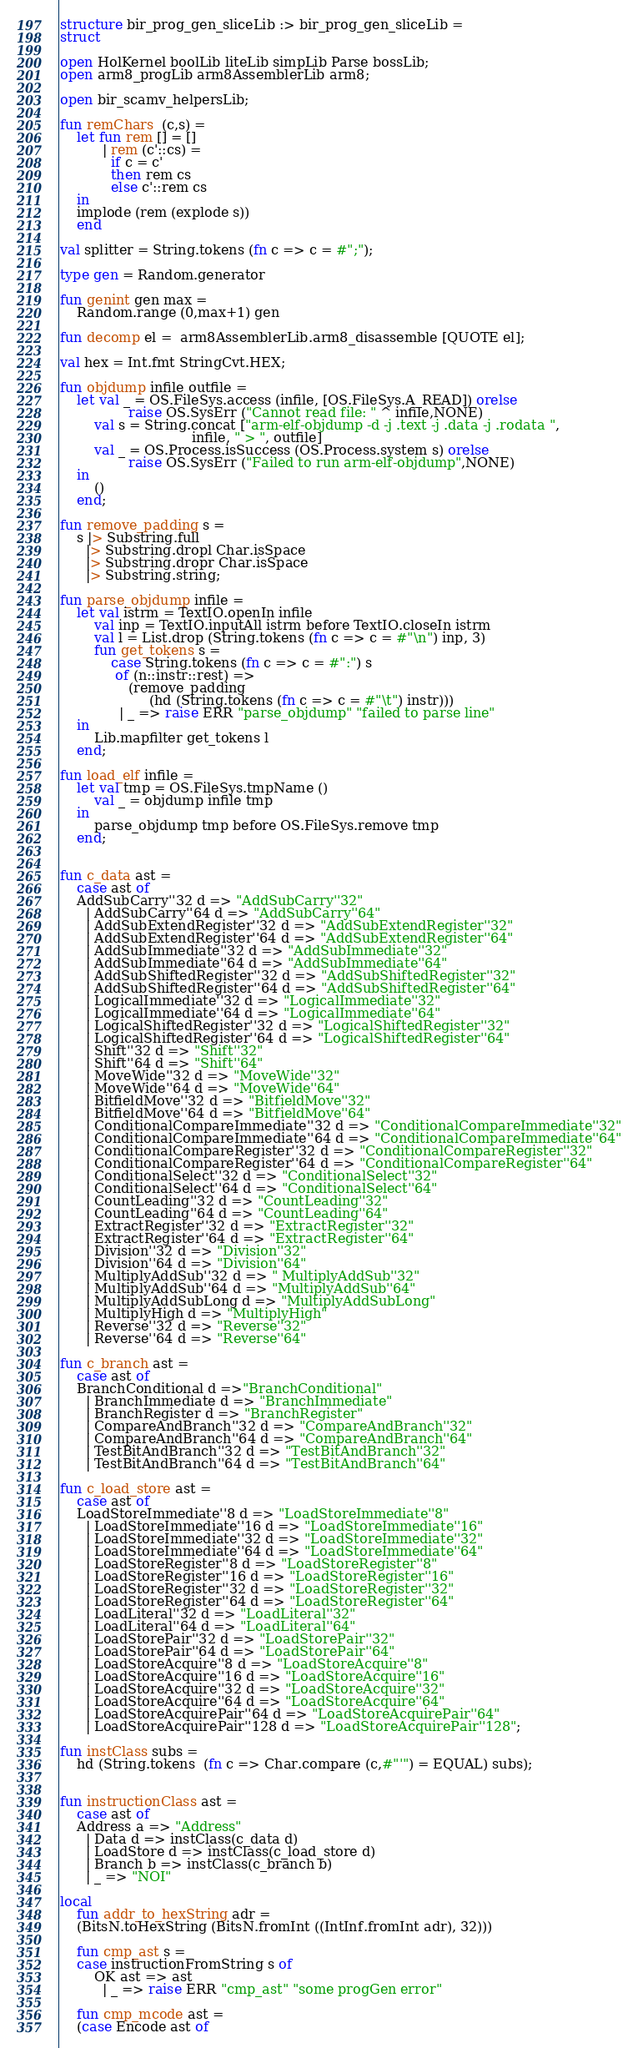<code> <loc_0><loc_0><loc_500><loc_500><_SML_>structure bir_prog_gen_sliceLib :> bir_prog_gen_sliceLib =
struct

open HolKernel boolLib liteLib simpLib Parse bossLib;
open arm8_progLib arm8AssemblerLib arm8;

open bir_scamv_helpersLib;
     
fun remChars  (c,s) =
    let fun rem [] = []
          | rem (c'::cs) =
            if c = c'
            then rem cs
            else c'::rem cs
    in
	implode (rem (explode s)) 
    end

val splitter = String.tokens (fn c => c = #";");

type gen = Random.generator

fun genint gen max =
    Random.range (0,max+1) gen     

fun decomp el =  arm8AssemblerLib.arm8_disassemble [QUOTE el];

val hex = Int.fmt StringCvt.HEX;

fun objdump infile outfile =
    let val _ = OS.FileSys.access (infile, [OS.FileSys.A_READ]) orelse
                raise OS.SysErr ("Cannot read file: " ^ infile,NONE)
        val s = String.concat ["arm-elf-objdump -d -j .text -j .data -j .rodata ",
                               infile, " > ", outfile]
        val _ = OS.Process.isSuccess (OS.Process.system s) orelse
                raise OS.SysErr ("Failed to run arm-elf-objdump",NONE)
    in
        ()
    end;

fun remove_padding s =
    s |> Substring.full
      |> Substring.dropl Char.isSpace
      |> Substring.dropr Char.isSpace
      |> Substring.string;

fun parse_objdump infile =
    let val istrm = TextIO.openIn infile
        val inp = TextIO.inputAll istrm before TextIO.closeIn istrm
        val l = List.drop (String.tokens (fn c => c = #"\n") inp, 3)
        fun get_tokens s =
            case String.tokens (fn c => c = #":") s
             of (n::instr::rest) =>
                (remove_padding
                     (hd (String.tokens (fn c => c = #"\t") instr)))
              | _ => raise ERR "parse_objdump" "failed to parse line"
    in
        Lib.mapfilter get_tokens l
    end;

fun load_elf infile =
    let val tmp = OS.FileSys.tmpName ()
        val _ = objdump infile tmp
    in
        parse_objdump tmp before OS.FileSys.remove tmp
    end;


fun c_data ast =
    case ast of
	AddSubCarry''32 d => "AddSubCarry''32"
      | AddSubCarry''64 d => "AddSubCarry''64"
      | AddSubExtendRegister''32 d => "AddSubExtendRegister''32"
      | AddSubExtendRegister''64 d => "AddSubExtendRegister''64"
      | AddSubImmediate''32 d => "AddSubImmediate''32"
      | AddSubImmediate''64 d => "AddSubImmediate''64"
      | AddSubShiftedRegister''32 d => "AddSubShiftedRegister''32"
      | AddSubShiftedRegister''64 d => "AddSubShiftedRegister''64"
      | LogicalImmediate''32 d => "LogicalImmediate''32"
      | LogicalImmediate''64 d => "LogicalImmediate''64"
      | LogicalShiftedRegister''32 d => "LogicalShiftedRegister''32"
      | LogicalShiftedRegister''64 d => "LogicalShiftedRegister''64"
      | Shift''32 d => "Shift''32"
      | Shift''64 d => "Shift''64"
      | MoveWide''32 d => "MoveWide''32"
      | MoveWide''64 d => "MoveWide''64"
      | BitfieldMove''32 d => "BitfieldMove''32"
      | BitfieldMove''64 d => "BitfieldMove''64"
      | ConditionalCompareImmediate''32 d => "ConditionalCompareImmediate''32"
      | ConditionalCompareImmediate''64 d => "ConditionalCompareImmediate''64"
      | ConditionalCompareRegister''32 d => "ConditionalCompareRegister''32"
      | ConditionalCompareRegister''64 d => "ConditionalCompareRegister''64"
      | ConditionalSelect''32 d => "ConditionalSelect''32"
      | ConditionalSelect''64 d => "ConditionalSelect''64"
      | CountLeading''32 d => "CountLeading''32"
      | CountLeading''64 d => "CountLeading''64"
      | ExtractRegister''32 d => "ExtractRegister''32"
      | ExtractRegister''64 d => "ExtractRegister''64"
      | Division''32 d => "Division''32"
      | Division''64 d => "Division''64"
      | MultiplyAddSub''32 d => " MultiplyAddSub''32"
      | MultiplyAddSub''64 d => "MultiplyAddSub''64"
      | MultiplyAddSubLong d => "MultiplyAddSubLong"
      | MultiplyHigh d => "MultiplyHigh"
      | Reverse''32 d => "Reverse''32"
      | Reverse''64 d => "Reverse''64"

fun c_branch ast =
    case ast of
	BranchConditional d =>"BranchConditional"
      | BranchImmediate d => "BranchImmediate"
      | BranchRegister d => "BranchRegister"
      | CompareAndBranch''32 d => "CompareAndBranch''32"
      | CompareAndBranch''64 d => "CompareAndBranch''64"
      | TestBitAndBranch''32 d => "TestBitAndBranch''32"
      | TestBitAndBranch''64 d => "TestBitAndBranch''64"

fun c_load_store ast =
    case ast of
	LoadStoreImmediate''8 d => "LoadStoreImmediate''8"
      | LoadStoreImmediate''16 d => "LoadStoreImmediate''16"
      | LoadStoreImmediate''32 d => "LoadStoreImmediate''32"
      | LoadStoreImmediate''64 d => "LoadStoreImmediate''64"
      | LoadStoreRegister''8 d => "LoadStoreRegister''8"
      | LoadStoreRegister''16 d => "LoadStoreRegister''16"
      | LoadStoreRegister''32 d => "LoadStoreRegister''32"
      | LoadStoreRegister''64 d => "LoadStoreRegister''64"
      | LoadLiteral''32 d => "LoadLiteral''32"
      | LoadLiteral''64 d => "LoadLiteral''64"
      | LoadStorePair''32 d => "LoadStorePair''32"
      | LoadStorePair''64 d => "LoadStorePair''64"
      | LoadStoreAcquire''8 d => "LoadStoreAcquire''8"
      | LoadStoreAcquire''16 d => "LoadStoreAcquire''16"
      | LoadStoreAcquire''32 d => "LoadStoreAcquire''32"
      | LoadStoreAcquire''64 d => "LoadStoreAcquire''64"
      | LoadStoreAcquirePair''64 d => "LoadStoreAcquirePair''64"
      | LoadStoreAcquirePair''128 d => "LoadStoreAcquirePair''128";

fun instClass subs =
    hd (String.tokens  (fn c => Char.compare (c,#"'") = EQUAL) subs);


fun instructionClass ast =
    case ast of
	Address a => "Address"
      | Data d => instClass(c_data d)
      | LoadStore d => instClass(c_load_store d)
      | Branch b => instClass(c_branch b)
      | _ => "NOI"

local 
    fun addr_to_hexString adr =
	(BitsN.toHexString (BitsN.fromInt ((IntInf.fromInt adr), 32)))

    fun cmp_ast s =
	case instructionFromString s of
	    OK ast => ast
          | _ => raise ERR "cmp_ast" "some progGen error"

    fun cmp_mcode ast = 
	(case Encode ast of</code> 